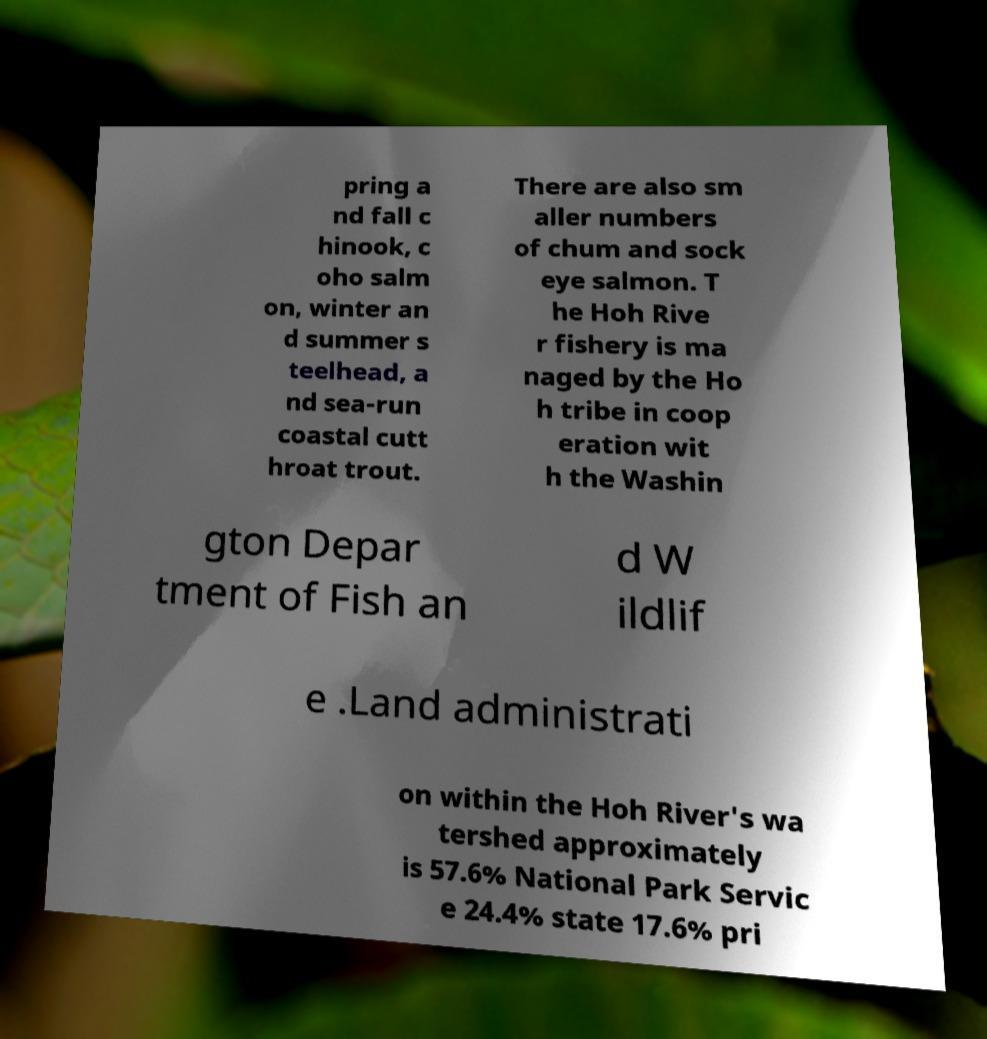Please identify and transcribe the text found in this image. pring a nd fall c hinook, c oho salm on, winter an d summer s teelhead, a nd sea-run coastal cutt hroat trout. There are also sm aller numbers of chum and sock eye salmon. T he Hoh Rive r fishery is ma naged by the Ho h tribe in coop eration wit h the Washin gton Depar tment of Fish an d W ildlif e .Land administrati on within the Hoh River's wa tershed approximately is 57.6% National Park Servic e 24.4% state 17.6% pri 